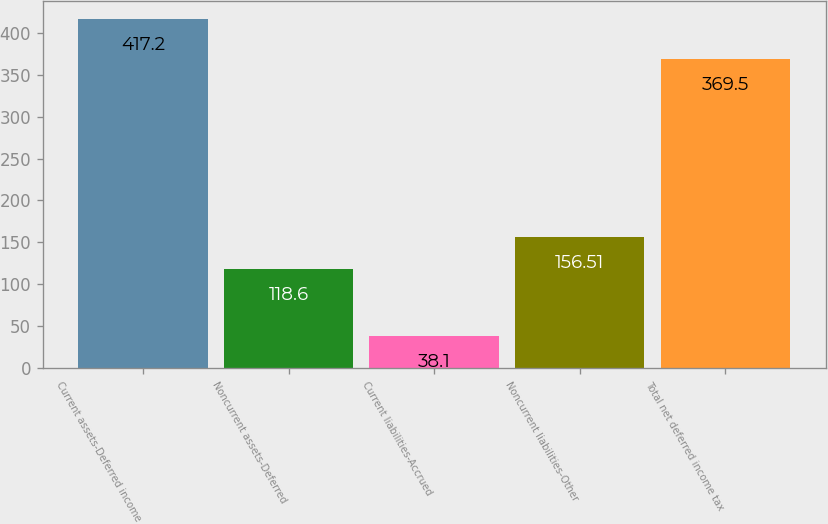Convert chart. <chart><loc_0><loc_0><loc_500><loc_500><bar_chart><fcel>Current assets-Deferred income<fcel>Noncurrent assets-Deferred<fcel>Current liabilities-Accrued<fcel>Noncurrent liabilities-Other<fcel>Total net deferred income tax<nl><fcel>417.2<fcel>118.6<fcel>38.1<fcel>156.51<fcel>369.5<nl></chart> 